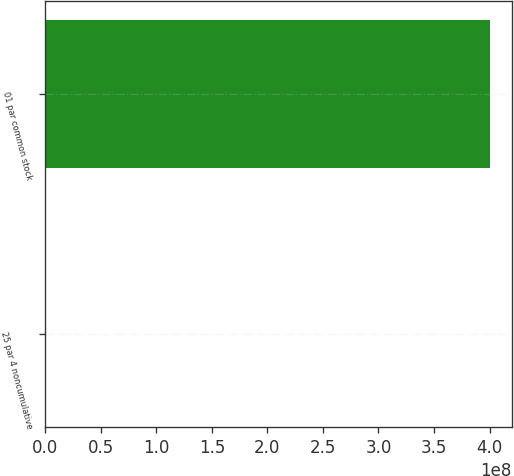Convert chart. <chart><loc_0><loc_0><loc_500><loc_500><bar_chart><fcel>25 par 4 noncumulative<fcel>01 par common stock<nl><fcel>840000<fcel>4e+08<nl></chart> 